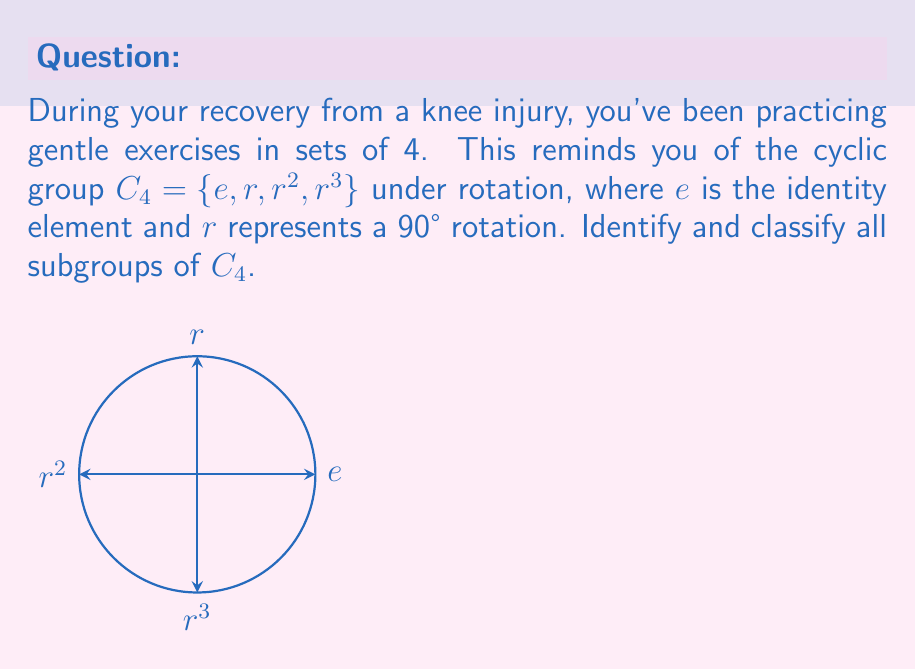Give your solution to this math problem. Let's approach this step-by-step:

1) First, recall that a subgroup must contain the identity element and be closed under the group operation.

2) The trivial subgroup: $\{e\}$ is always a subgroup of any group.

3) The whole group $C_4 = \{e, r, r^2, r^3\}$ is also a subgroup of itself.

4) Now, let's consider proper subgroups:

   a) $\{e, r^2\}$: This is a subgroup because $(r^2)^2 = e$.
   
   b) $\{e, r, r^2, r^3\}$: This is the entire group $C_4$.

5) We can classify these subgroups:

   - $\{e\}$ is isomorphic to the trivial group.
   - $\{e, r^2\}$ is isomorphic to $C_2$ (cyclic group of order 2).
   - $C_4$ itself is, of course, isomorphic to $C_4$.

6) We can verify that there are no other subgroups:
   - $\{e, r\}$ is not a subgroup because $r^2 \notin \{e, r\}$.
   - $\{e, r^3\}$ is not a subgroup because $(r^3)^2 = r^2 \notin \{e, r^3\}$.

Therefore, we have identified all subgroups of $C_4$.
Answer: The subgroups of $C_4$ are $\{e\}$, $\{e, r^2\}$, and $C_4$ itself, isomorphic to the trivial group, $C_2$, and $C_4$ respectively. 